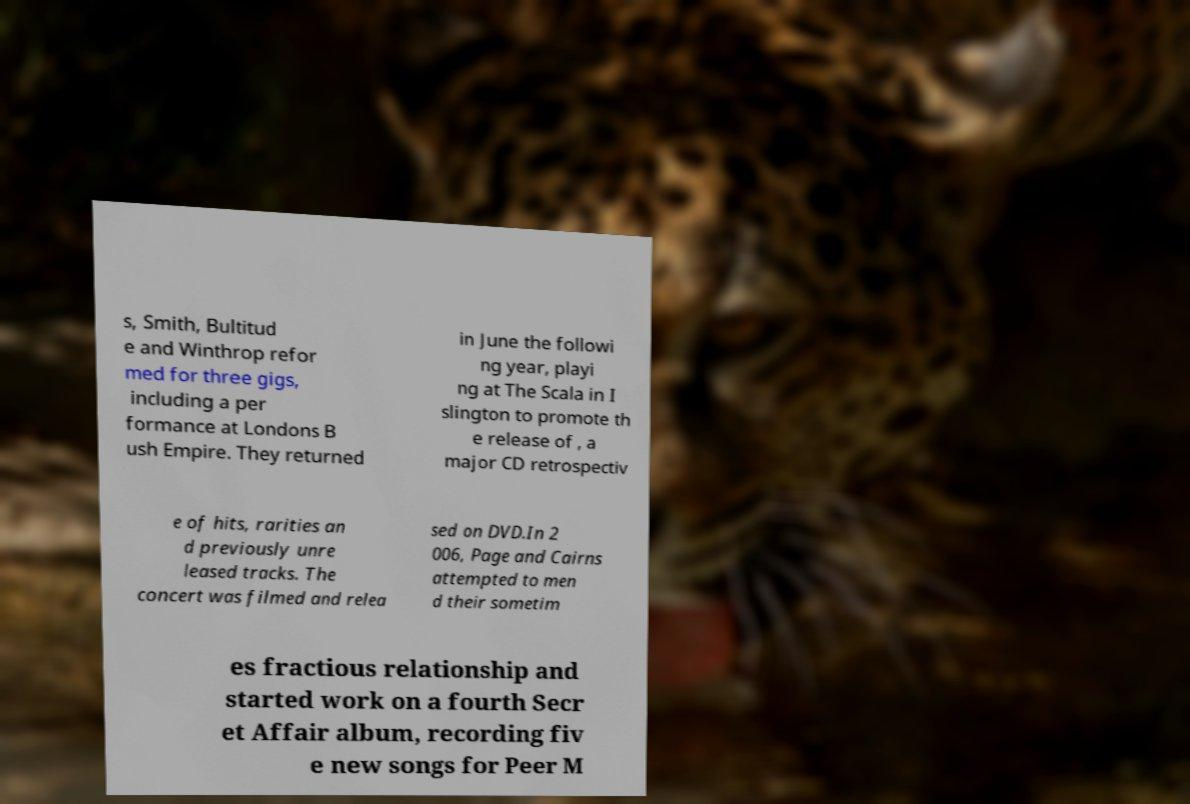There's text embedded in this image that I need extracted. Can you transcribe it verbatim? s, Smith, Bultitud e and Winthrop refor med for three gigs, including a per formance at Londons B ush Empire. They returned in June the followi ng year, playi ng at The Scala in I slington to promote th e release of , a major CD retrospectiv e of hits, rarities an d previously unre leased tracks. The concert was filmed and relea sed on DVD.In 2 006, Page and Cairns attempted to men d their sometim es fractious relationship and started work on a fourth Secr et Affair album, recording fiv e new songs for Peer M 